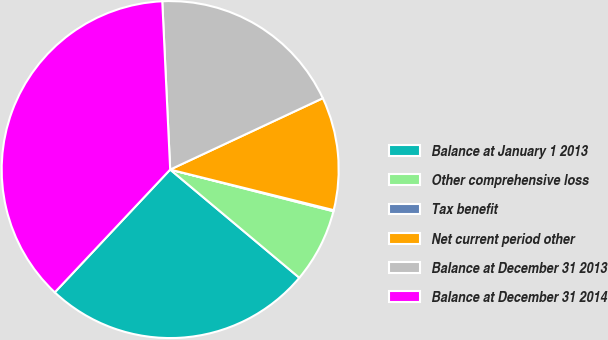Convert chart. <chart><loc_0><loc_0><loc_500><loc_500><pie_chart><fcel>Balance at January 1 2013<fcel>Other comprehensive loss<fcel>Tax benefit<fcel>Net current period other<fcel>Balance at December 31 2013<fcel>Balance at December 31 2014<nl><fcel>25.91%<fcel>7.12%<fcel>0.11%<fcel>10.83%<fcel>18.79%<fcel>37.25%<nl></chart> 